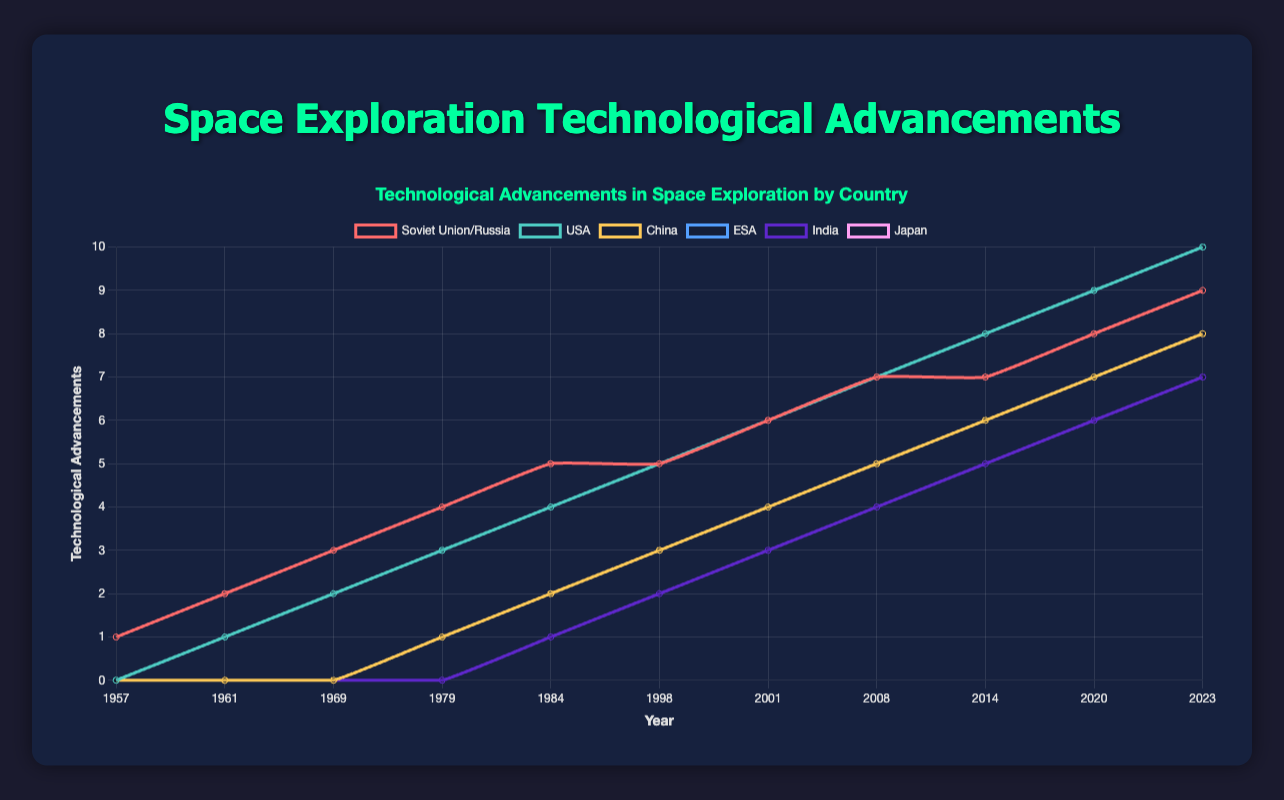What country had the highest technological advancements in space exploration in 2023? From the line plot, we observe that the USA had the highest value in 2023, based on the y-axis value.
Answer: USA How many technological advancements were made by China in 2008? The line representing China shows a value of 5 for the year 2008.
Answer: 5 Which countries showed an equal number of technological advancements in 1979? By examining the lines for each country, both China and ESA show the same value of 1 for the year 1979.
Answer: China and ESA What is the difference in technological advancements between India and Japan in 1998? The values for India and Japan both show 2 in 1998. The difference is 2 - 2 = 0.
Answer: 0 Which country experienced the most consistent growth in technological advancements from 1957 to 2023? By observing the lines, we see that the USA's line consistently increases every year without any drop, indicating the most consistent growth.
Answer: USA How many total technological advancements were made by the Soviet Union/Russia from 1957 to 2023? Add up the values for each year for the Soviet Union/Russia: 1 (1957) + 2 (1961) + 3 (1969) + 4 (1979) + 5 (1984) + 5 (1998) + 6 (2001) + 7 (2008) + 7 (2014) + 8 (2020) + 9 (2023) = 57
Answer: 57 What was the average technological advancement score for ESA from 1979 to 2023? Sum up the ESA scores for the relevant years and divide by the number of terms: (1 + 2 + 3 + 4 + 5 + 6 + 7 + 8) / 8 = 36 / 8 = 4.5
Answer: 4.5 In which year did Japan and India first achieve the same number of technological advancements? Both Japan and India have the same value of 1 in 1984, marking the first time they achieve the same number.
Answer: 1984 How many technological advancements did the USA achieve more than China by 2023? USA's value in 2023 is 10, and China's value is 8. The difference is 10 - 8 = 2.
Answer: 2 